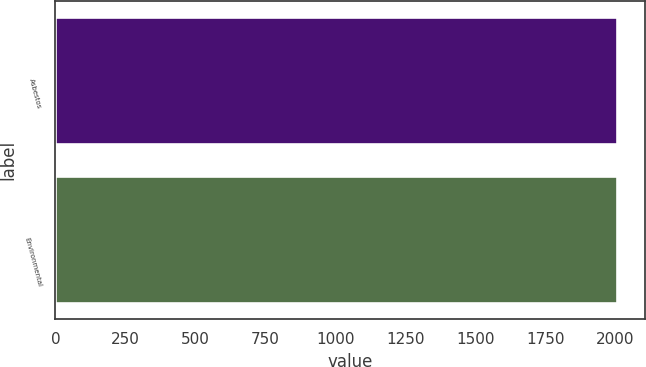Convert chart. <chart><loc_0><loc_0><loc_500><loc_500><bar_chart><fcel>Asbestos<fcel>Environmental<nl><fcel>2007<fcel>2007.1<nl></chart> 